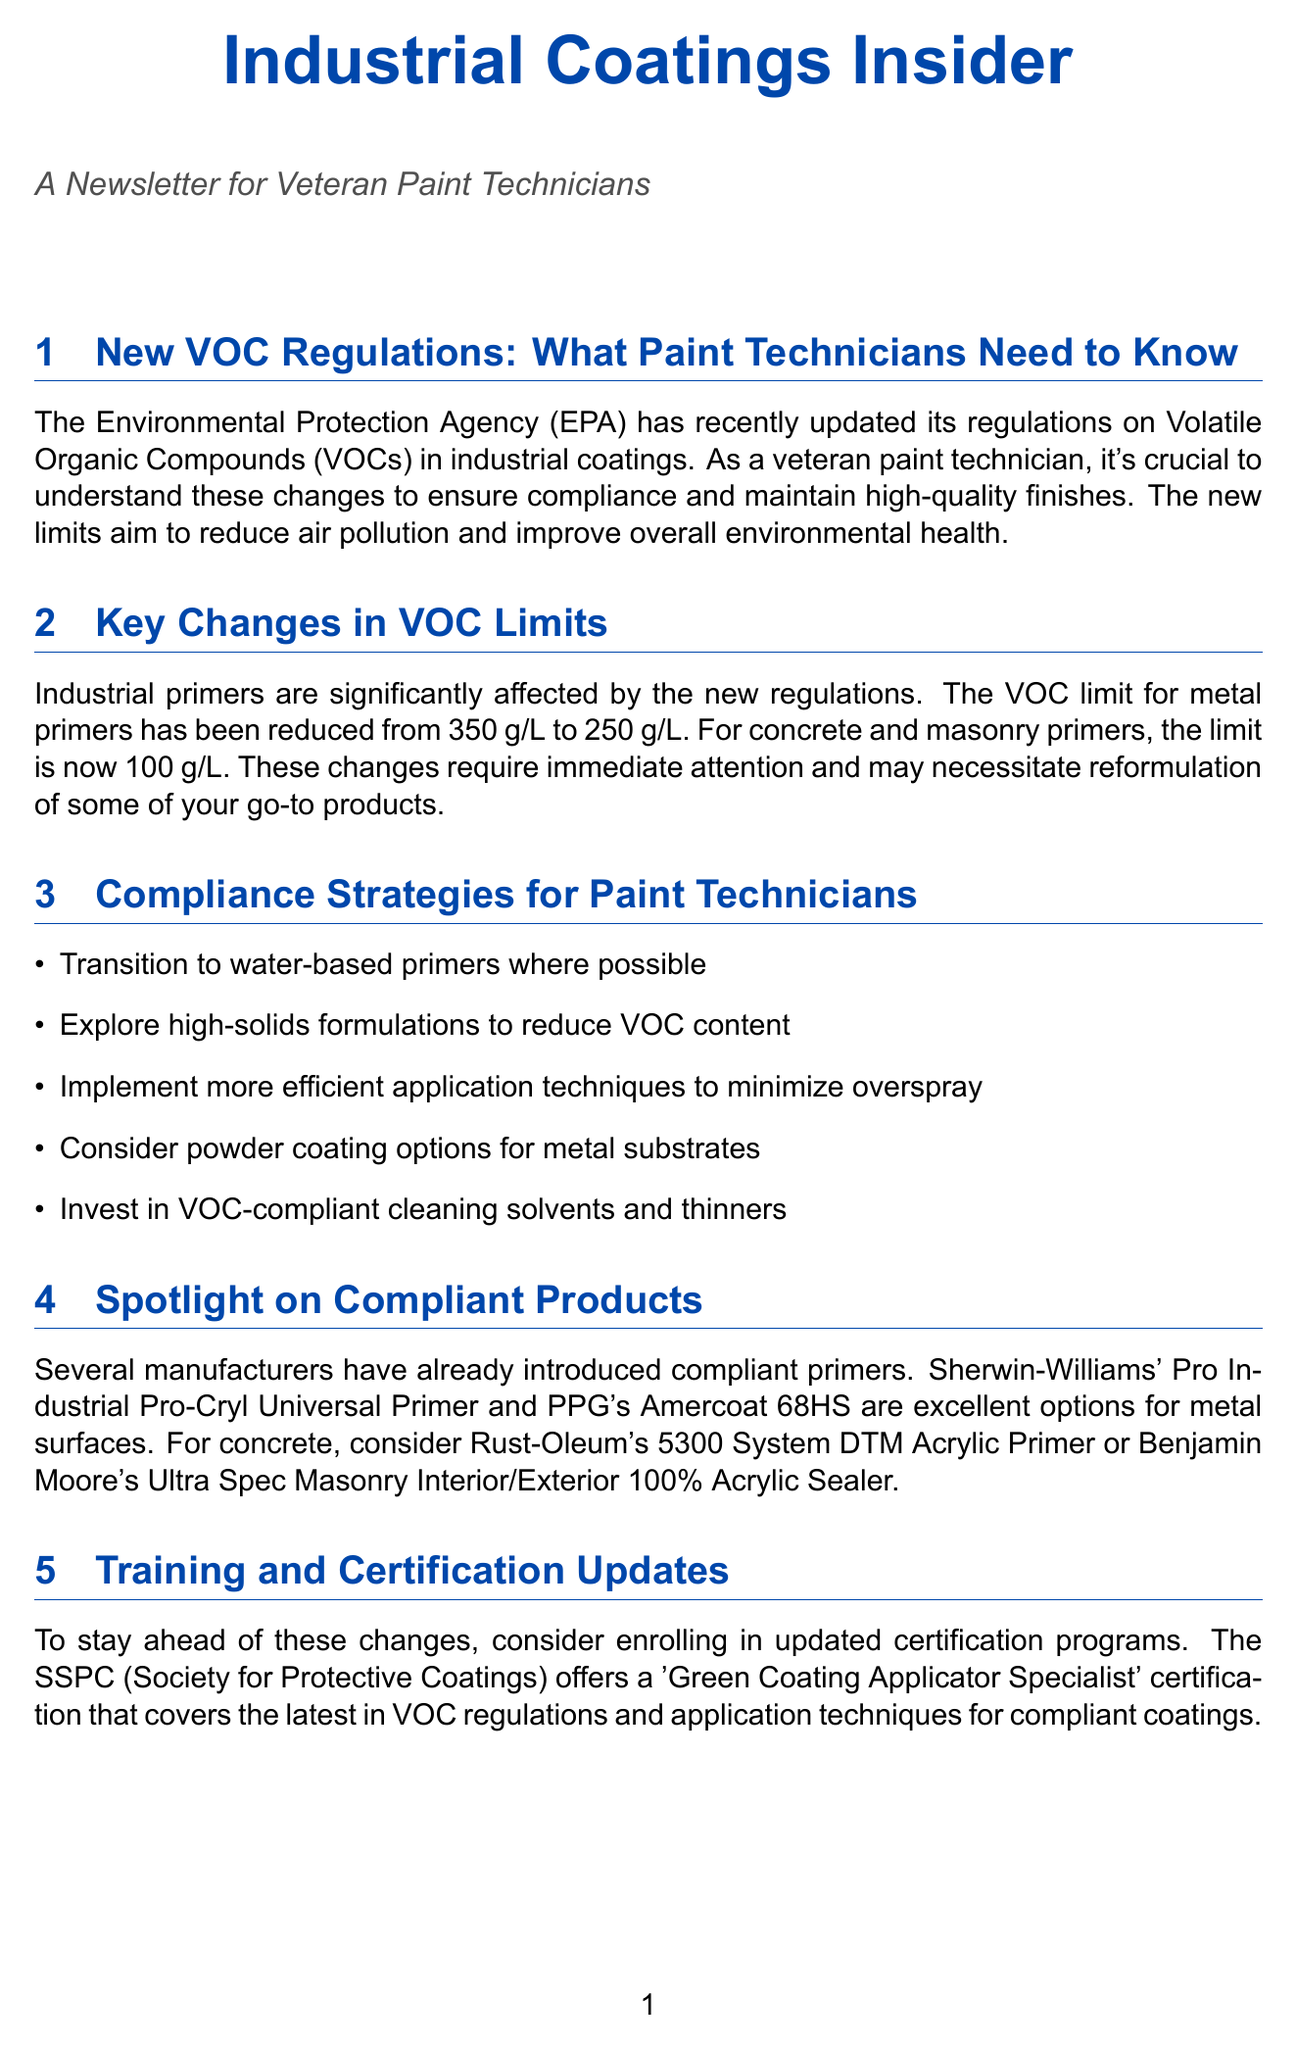what is the new VOC limit for metal primers? The new VOC limit for metal primers has been reduced from 350 g/L to 250 g/L.
Answer: 250 g/L what is the VOC limit for concrete primers? The document specifies that the VOC limit for concrete and masonry primers is now 100 g/L.
Answer: 100 g/L which certification is offered by SSPC? The Society for Protective Coatings offers a 'Green Coating Applicator Specialist' certification.
Answer: Green Coating Applicator Specialist what has been reduced by 40% in the case study? The case study mentions that a major automotive parts manufacturer reduced VOC emissions by 40%.
Answer: VOC emissions what are two compliance strategies suggested for paint technicians? The document lists several strategies, including transitioning to water-based primers and exploring high-solids formulations.
Answer: Transition to water-based primers, explore high-solids formulations which product is highlighted for metal surfaces? The document highlights Sherwin-Williams' Pro Industrial Pro-Cryl Universal Primer for metal surfaces.
Answer: Sherwin-Williams' Pro Industrial Pro-Cryl Universal Primer what type of formulations can reduce VOC content? The content mentions exploring high-solids formulations as a strategy to reduce VOC content.
Answer: high-solids formulations what is the potential economic benefit of using eco-friendly coatings? The document states that long-term benefits include improved worker safety, reduced environmental impact, and potential tax incentives.
Answer: potential tax incentives 